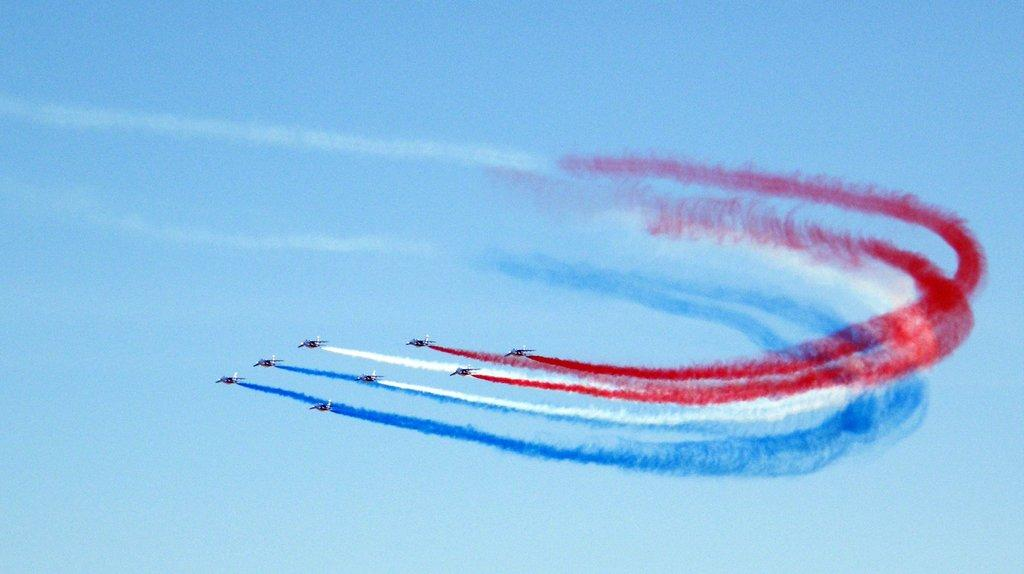What is the main subject of the image? The main subject of the image is many jets. What are the jets doing in the image? The jets are flying in the sky. What is coming out of the jets? The jets are exhausting smoke. What is unique about the smoke in the image? The smoke has different colors. What is visible at the top of the image? The sky is visible at the top of the image. What type of sack can be seen hanging from the jets in the image? There is no sack present in the image; the jets are exhausting smoke, not carrying any sacks. How does the turkey contribute to the image? There is no turkey present in the image; it is a scene of jets flying and exhausting smoke. 